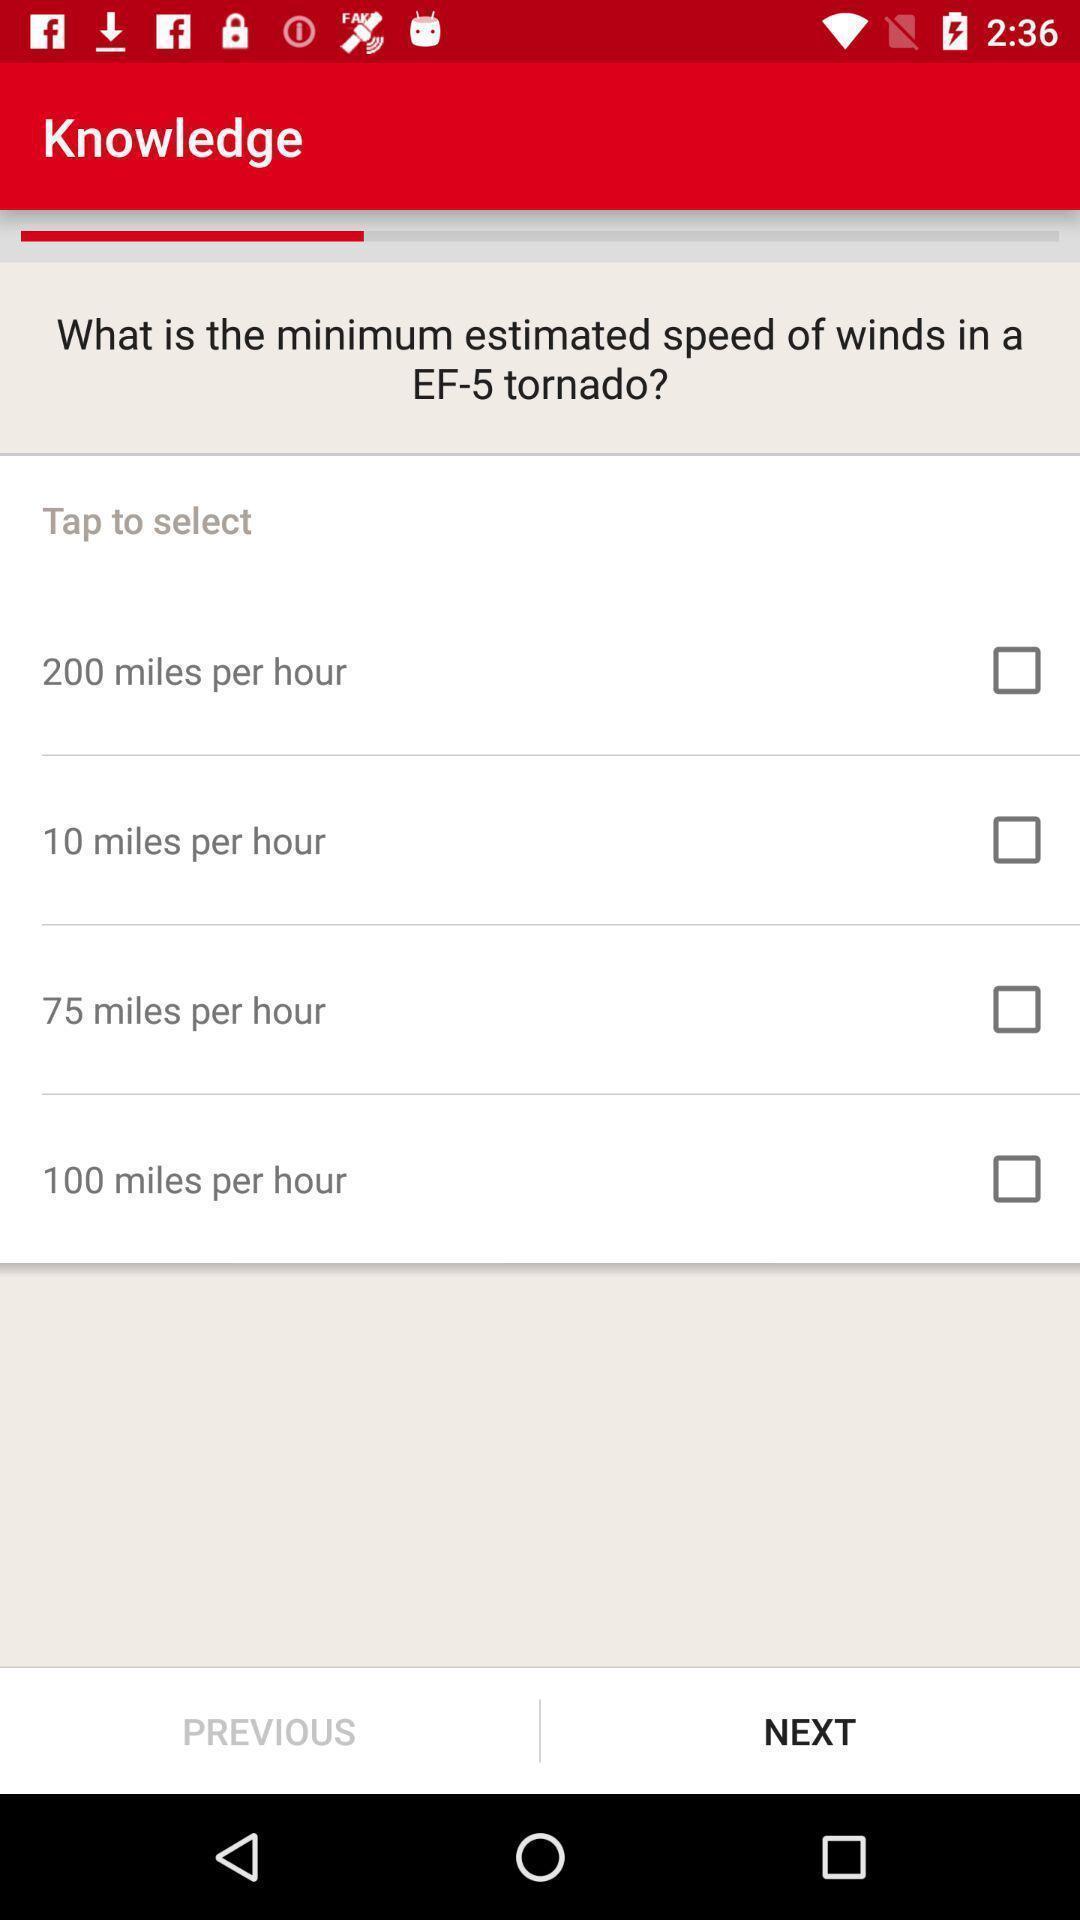Give me a summary of this screen capture. Page showing a question with multiple options on an app. 